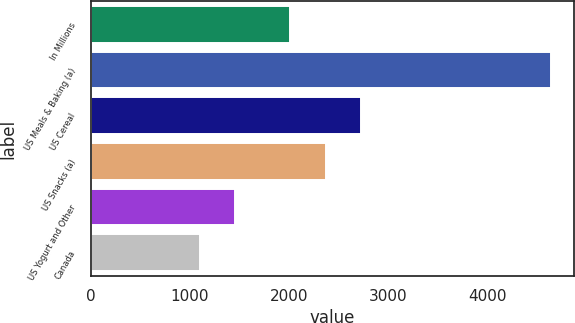Convert chart to OTSL. <chart><loc_0><loc_0><loc_500><loc_500><bar_chart><fcel>In Millions<fcel>US Meals & Baking (a)<fcel>US Cereal<fcel>US Snacks (a)<fcel>US Yogurt and Other<fcel>Canada<nl><fcel>2015<fcel>4644.1<fcel>2722.8<fcel>2368.9<fcel>1459<fcel>1105.1<nl></chart> 